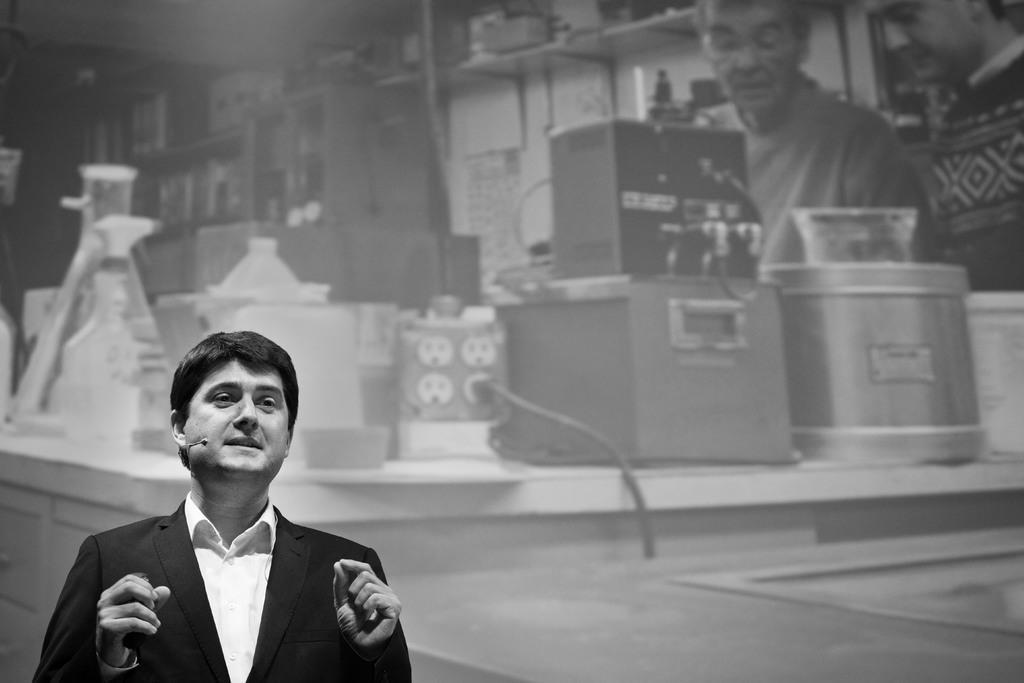Could you give a brief overview of what you see in this image? In this image, at the left side there is a man standing, in the background there are two persons standing and there are some boxes. 